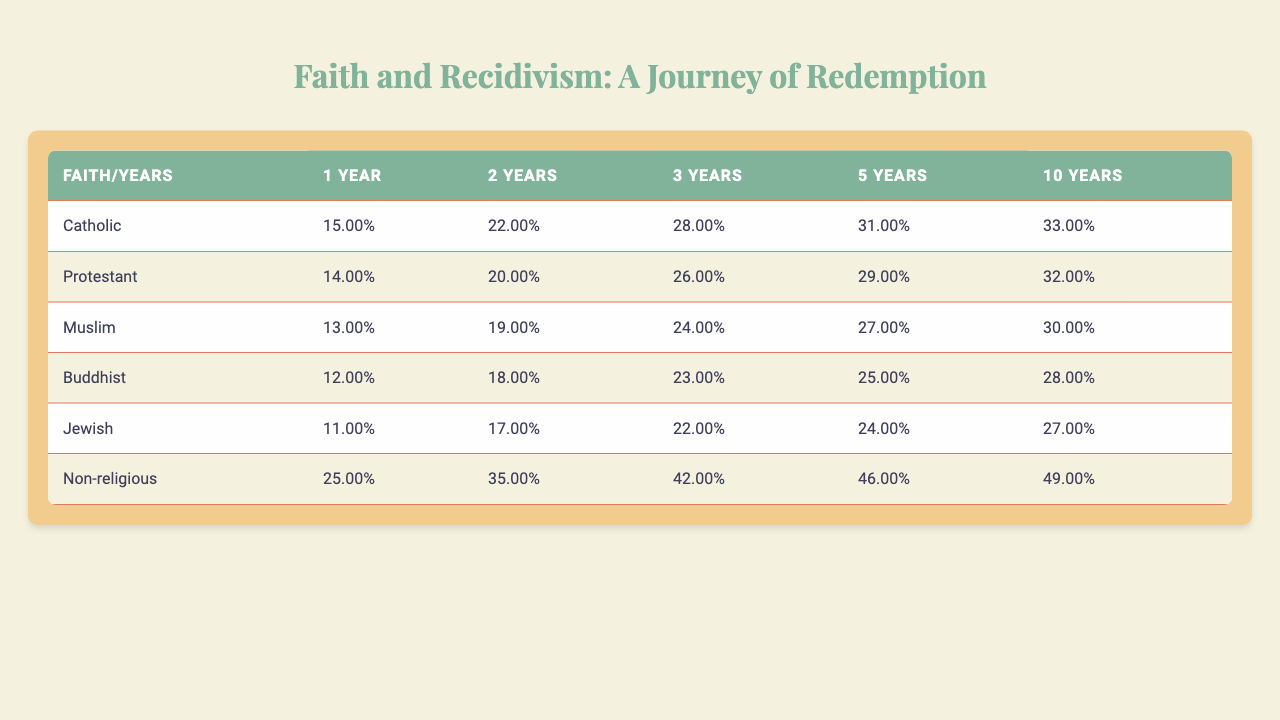What is the recidivism rate for Catholic ex-offenders after 1 year? The table shows that the recidivism rate for Catholics after 1 year is 15%.
Answer: 0.15 Which religious group has the highest recidivism rate after 5 years? The table indicates that the Non-religious group has the highest recidivism rate after 5 years at 49%.
Answer: Non-religious What is the average recidivism rate for Muslims over the 5 years? The average recidivism rate for Muslims over the 5 years is calculated as (0.13 + 0.19 + 0.24 + 0.27 + 0.30)/5 = 0.226 or 22.6%.
Answer: 0.226 Is the recidivism rate for Jewish ex-offenders decreasing over the years? By examining the rates (11%, 17%, 22%, 24%, 27%), they consistently increase, thus the rate is not decreasing.
Answer: No What is the difference in recidivism rates between Non-religious and Buddhist ex-offenders after 3 years? The recidivism rate for Non-religious is 42% and for Buddhist is 23%. The difference is 42% - 23% = 19%.
Answer: 19% Calculate the median recidivism rate for Catholic ex-offenders over the 5 years. The recidivism rates are 15%, 22%, 28%, 31%, and 33%. Sorting these, the median is the middle value, which is 28%.
Answer: 0.28 How does the recidivism rate for Protestant ex-offenders compare to the overall trend of increasing rates? The Protestant rates start at 14% and increase to 32% over the years, showing an overall increase which aligns with the trend.
Answer: Aligned with the trend After 10 years, what is the percentage of recidivism for Buddhists? According to the table, the percentage of recidivism for Buddhists after 10 years is 28%.
Answer: 0.28 What is the recidivism rate progression for ex-offenders of the Catholic faith from the first year to the fifth year? The progression shows 15% in year 1, increasing to 33% by year 5, indicating a clear upward trend over the 5-year period.
Answer: Upward trend Which faith-based prison program could potentially reduce recidivism rates the most based on the data shown for 1 year? Based on the data, Non-religious participants have the highest rate at 25%, while Buddhist has the lowest at 12%, hence Buddhist programs could potentially lessen rates more.
Answer: Buddhist programs could reduce recidivism more 